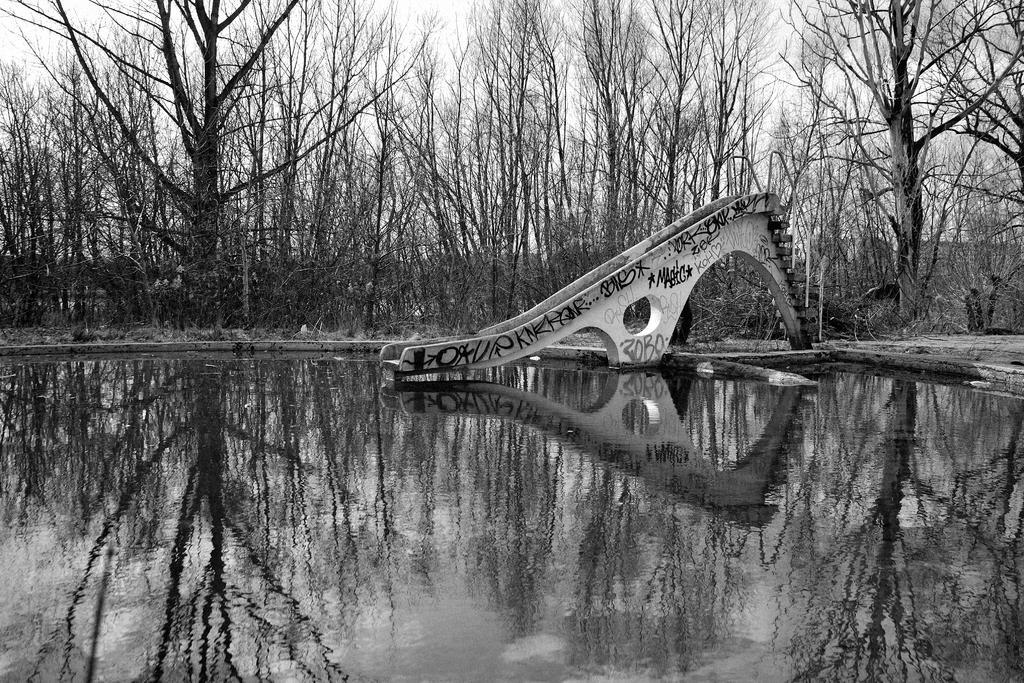How would you summarize this image in a sentence or two? It is the black and white image in which there is a slide in the water. In the background there are tall trees. At the bottom there is water. 